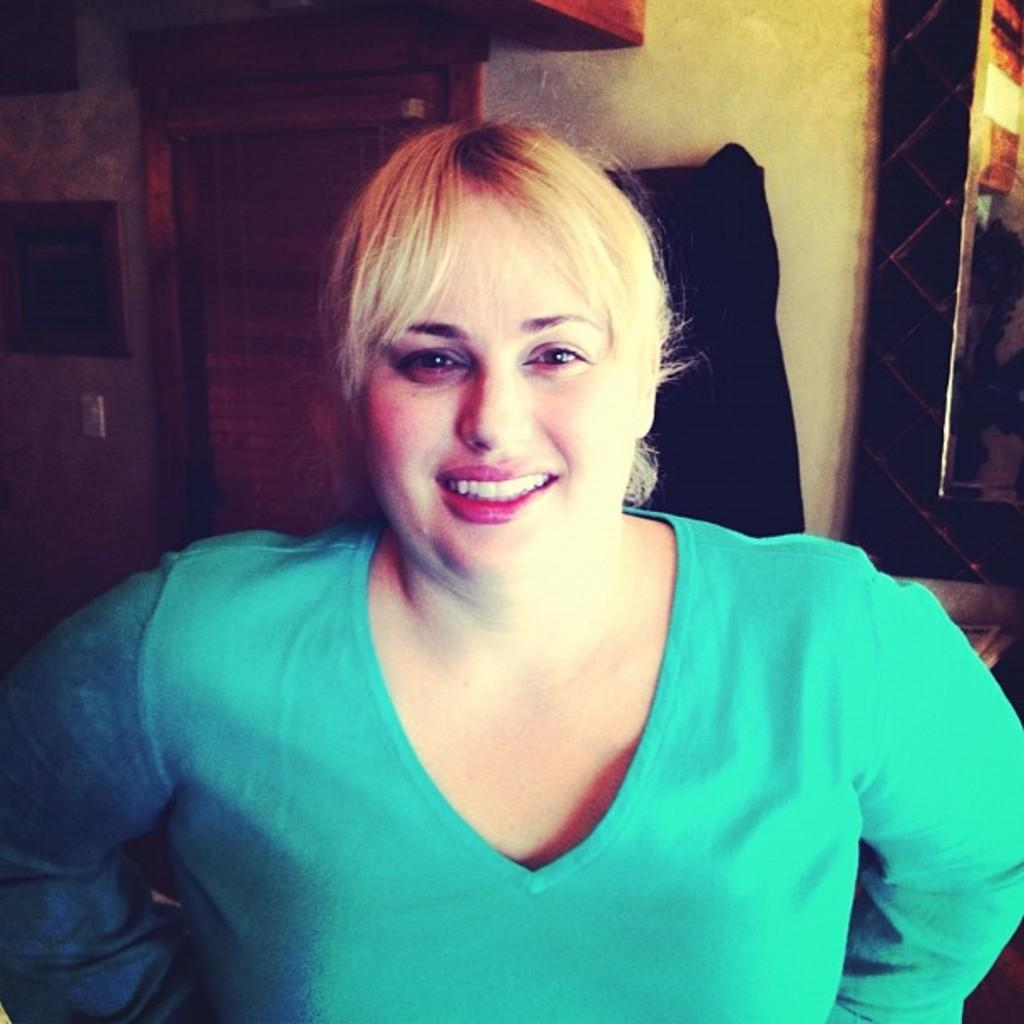What is present in the image? There is a person in the image. What is the person wearing? The person is wearing a green color top. What can be seen in the background of the image? There is a wall visible in the background of the image. Can you describe any other objects present in the background? There are a few objects present in the background of the image. What type of egg is the governor holding in the image? There is no governor or egg present in the image. How many feet can be seen in the image? There are no feet visible in the image. 